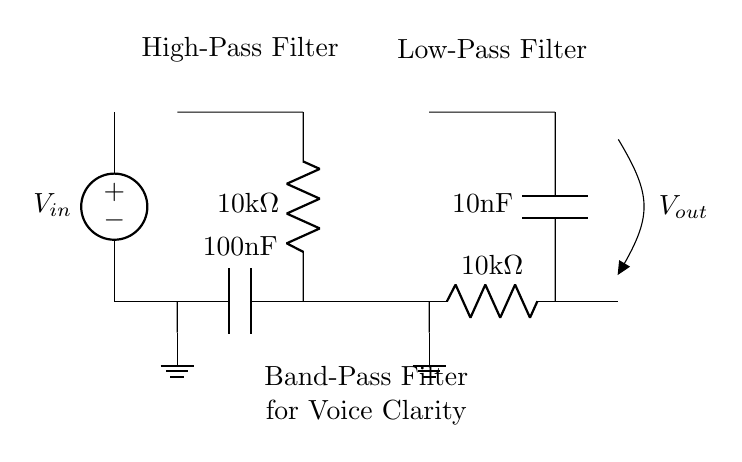What is the value of the capacitor in the high-pass filter? The high-pass filter section includes a capacitor denoted by "100nF," which indicates its capacitance value.
Answer: 100 nanofarads What is the value of the resistor in the low-pass filter? The low-pass filter section has a resistor labeled "10kΩ," which specifies its resistance.
Answer: 10 kilo-ohms What is the function of the two capacitors in the circuit? The two capacitors serve different roles: the first is in the high-pass filter to allow high frequencies to pass while blocking low frequencies, and the second is in the low-pass filter to permit low frequencies while blocking high frequencies, together creating a band-pass effect for voice clarity.
Answer: Filter frequencies What type of filter is represented by this circuit? The circuit diagram represents a band-pass filter, as it combines a high-pass filter and a low-pass filter to allow a specific frequency range to pass through while blocking others.
Answer: Band-pass filter How many resistors are used in this circuit? The circuit contains two resistors: one in the high-pass filter section and one in the low-pass filter section, which both contribute to the filter's cutoff frequencies.
Answer: Two What is the input voltage in the circuit? The input voltage is denoted as "V_in," and while the actual value is not specified in the diagram, it indicates that voltage is supplied to the circuit from this point.
Answer: V_in What is the intended application of this filter circuit? The filter circuit is designed to enhance voice clarity in intercom systems, particularly useful in government office settings where clear communication is essential.
Answer: Voice clarity in intercom systems 